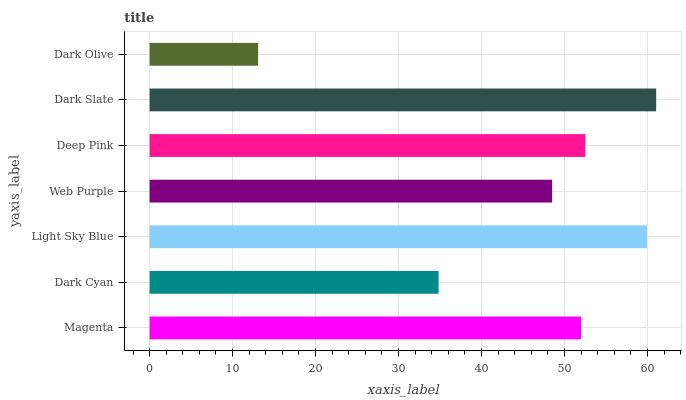Is Dark Olive the minimum?
Answer yes or no. Yes. Is Dark Slate the maximum?
Answer yes or no. Yes. Is Dark Cyan the minimum?
Answer yes or no. No. Is Dark Cyan the maximum?
Answer yes or no. No. Is Magenta greater than Dark Cyan?
Answer yes or no. Yes. Is Dark Cyan less than Magenta?
Answer yes or no. Yes. Is Dark Cyan greater than Magenta?
Answer yes or no. No. Is Magenta less than Dark Cyan?
Answer yes or no. No. Is Magenta the high median?
Answer yes or no. Yes. Is Magenta the low median?
Answer yes or no. Yes. Is Light Sky Blue the high median?
Answer yes or no. No. Is Dark Slate the low median?
Answer yes or no. No. 